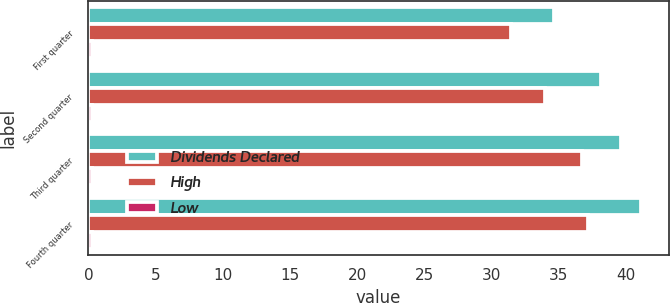Convert chart to OTSL. <chart><loc_0><loc_0><loc_500><loc_500><stacked_bar_chart><ecel><fcel>First quarter<fcel>Second quarter<fcel>Third quarter<fcel>Fourth quarter<nl><fcel>Dividends Declared<fcel>34.65<fcel>38.13<fcel>39.66<fcel>41.12<nl><fcel>High<fcel>31.42<fcel>33.99<fcel>36.72<fcel>37.18<nl><fcel>Low<fcel>0.26<fcel>0.26<fcel>0.28<fcel>0.28<nl></chart> 